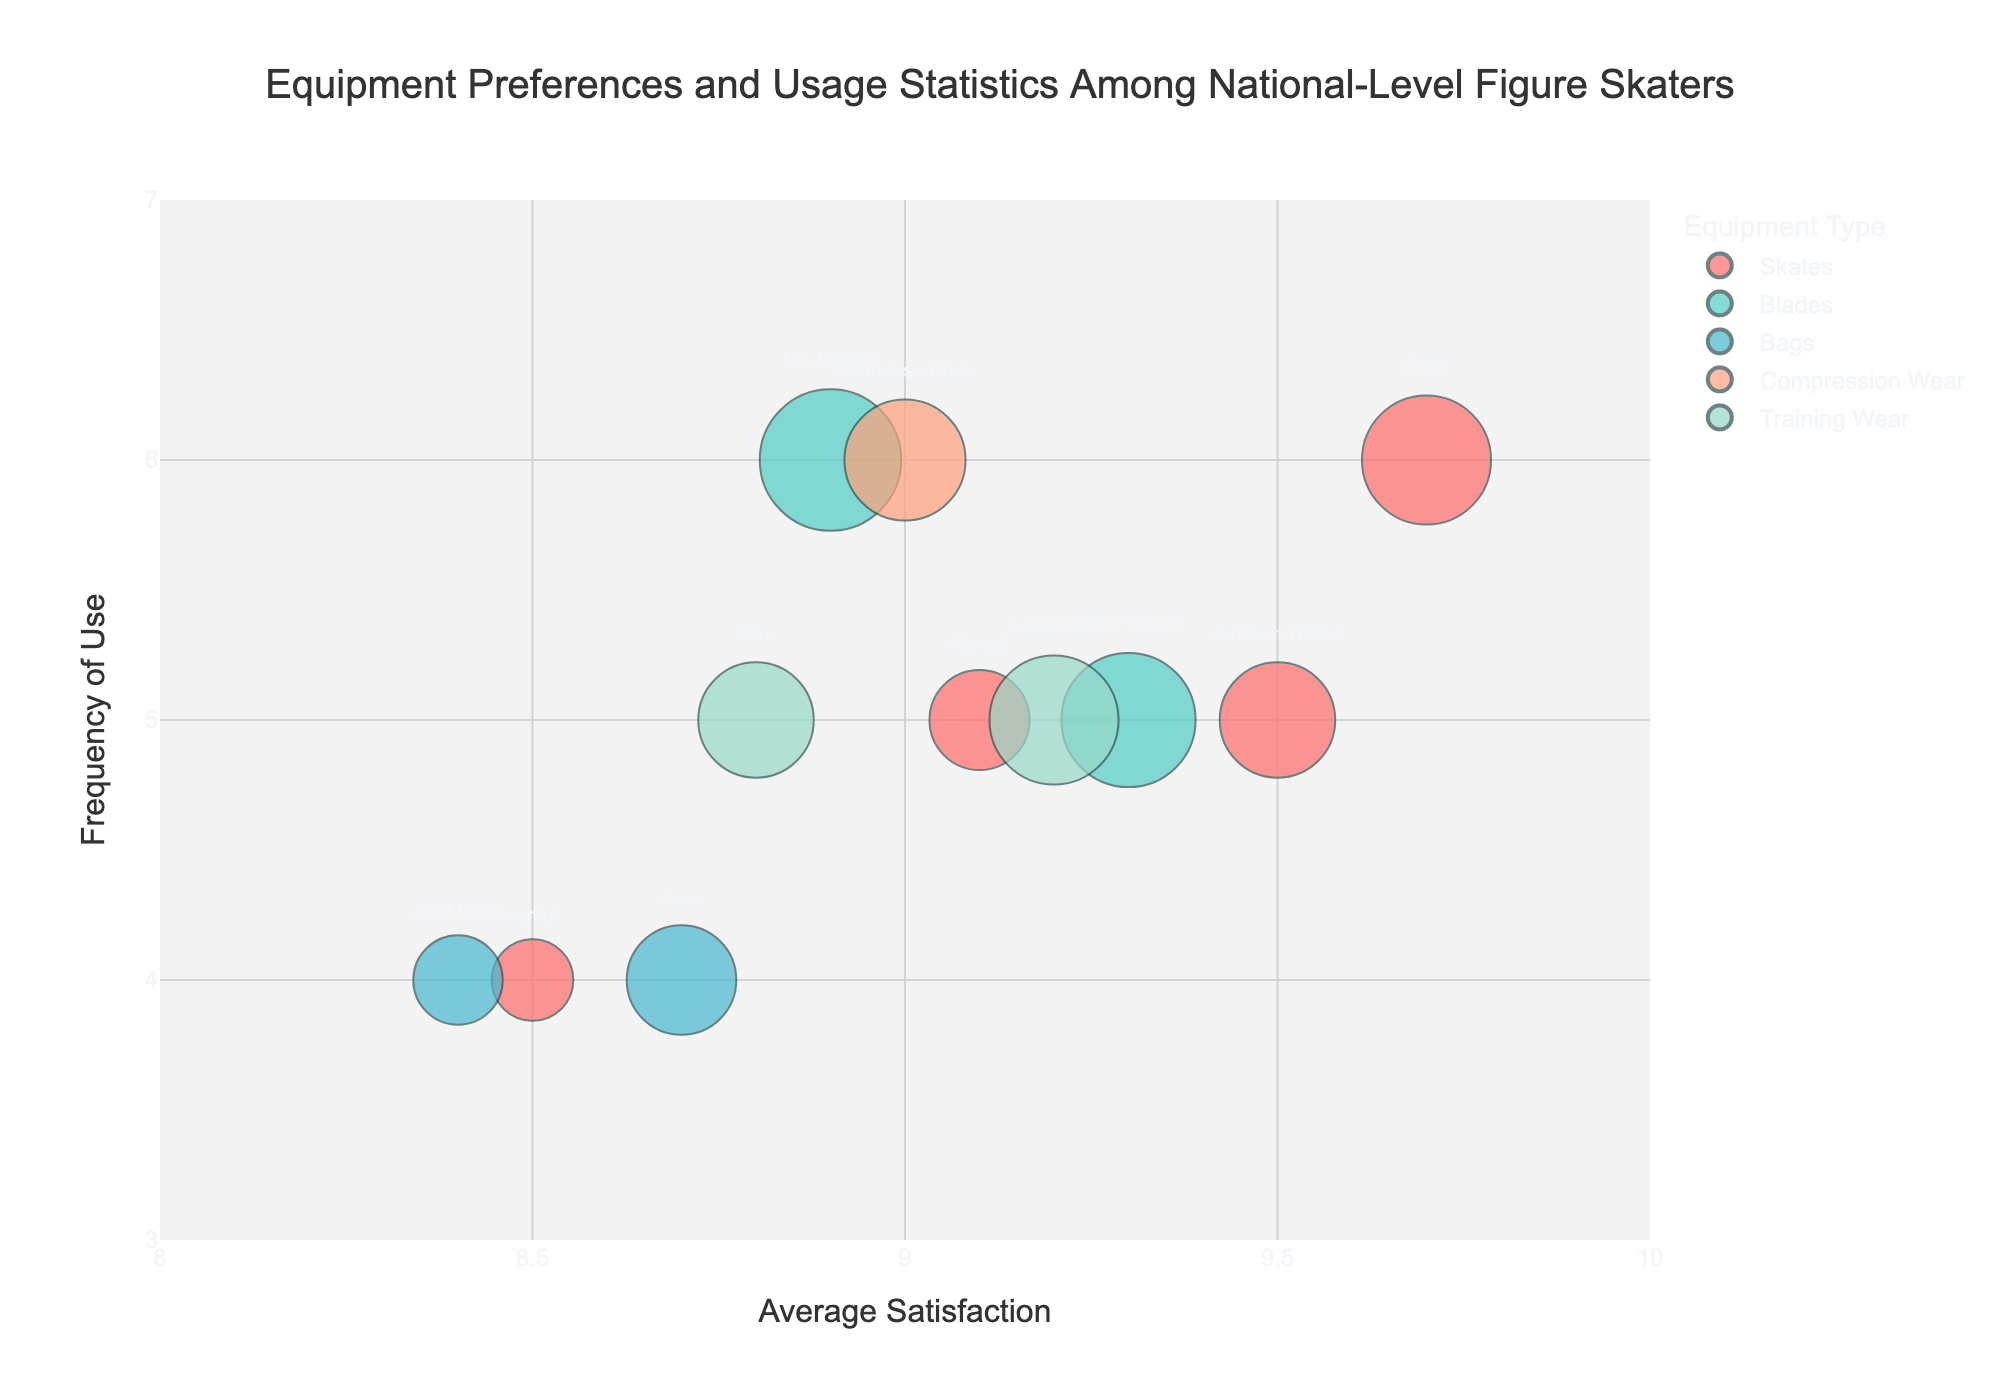What's the equipment type with the highest average satisfaction? By examining the x-axis, we see that "Edea" for skates has the highest average satisfaction score of 9.7.
Answer: Skates Which brand has the largest number of users? The size of the bubbles represents the number of users. "MK Blades" has the largest bubble, indicating it has the highest number of users, which is 30.
Answer: MK Blades How frequently are Riedell skates used? By looking at the y-axis corresponding to the "Riedell" brand, we see their usage frequency is 5.
Answer: 5 Which equipment type has the most entries in the chart? By counting the different colors representing each equipment type, "Skates" appear most frequently with four entries.
Answer: Skates Which brands have an average satisfaction greater than 9 but a frequency of use less than 6? Brands meeting these criteria are "Jackson Ultima" and "John Wilson" by examining both the x and y axes and their respective positions.
Answer: Jackson Ultima, John Wilson Which equipment type's bubbles are colored light blue? From the color mapping, we see that "Bags" have light blue bubbles.
Answer: Bags What is the range of average satisfaction scores for Compression Wear? Observing the x-axis, "Seamless Body" within Compression Wear ranges between 9.0.
Answer: 9.0 What is the equipment type with the least average satisfaction? By examining the x-axis, "Harlick" in "Skates" has the lowest average satisfaction of 8.5.
Answer: Skates Which bag brand has a higher average satisfaction, Zuca or Axel Bags? By comparing the x positions of bubbles for "Zuca" and "Axel Bags," "Zuca" has a higher average satisfaction at 8.7 versus 8.4 for "Axel Bags."
Answer: Zuca Is there any equipment type that has a frequency of use equal to 4 and has more than 10 users? By cross-referencing the y-axis for frequency and bubble sizes, "Zuca" and "Harlick" fit this criterion.
Answer: Zuca, Harlick 